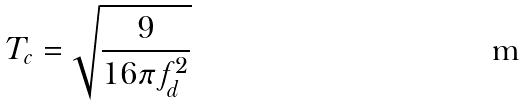Convert formula to latex. <formula><loc_0><loc_0><loc_500><loc_500>T _ { c } = \sqrt { \frac { 9 } { 1 6 \pi f _ { d } ^ { 2 } } }</formula> 